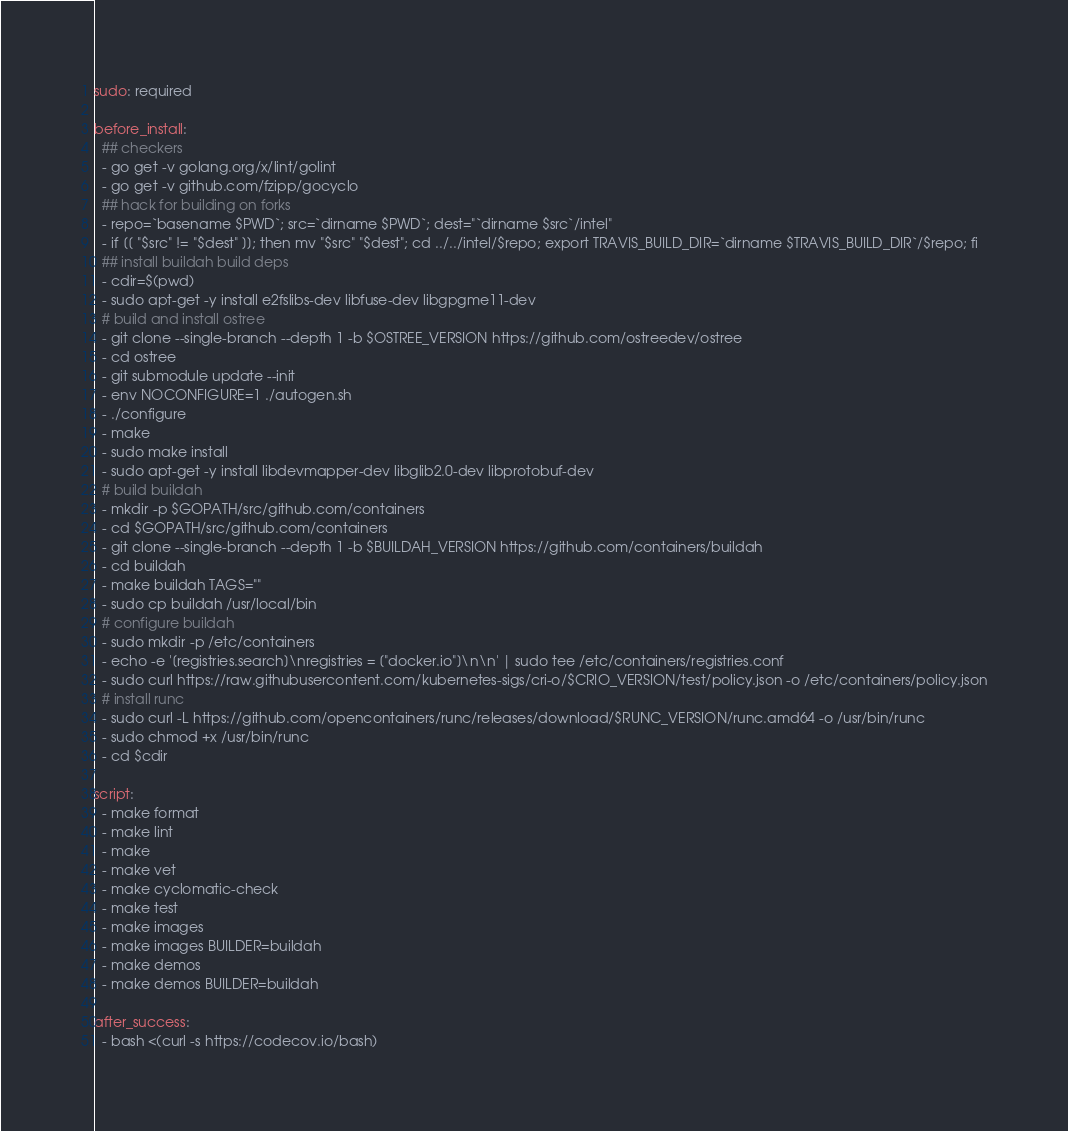Convert code to text. <code><loc_0><loc_0><loc_500><loc_500><_YAML_>
sudo: required

before_install:
  ## checkers
  - go get -v golang.org/x/lint/golint
  - go get -v github.com/fzipp/gocyclo
  ## hack for building on forks
  - repo=`basename $PWD`; src=`dirname $PWD`; dest="`dirname $src`/intel"
  - if [[ "$src" != "$dest" ]]; then mv "$src" "$dest"; cd ../../intel/$repo; export TRAVIS_BUILD_DIR=`dirname $TRAVIS_BUILD_DIR`/$repo; fi
  ## install buildah build deps
  - cdir=$(pwd)
  - sudo apt-get -y install e2fslibs-dev libfuse-dev libgpgme11-dev
  # build and install ostree
  - git clone --single-branch --depth 1 -b $OSTREE_VERSION https://github.com/ostreedev/ostree
  - cd ostree
  - git submodule update --init
  - env NOCONFIGURE=1 ./autogen.sh
  - ./configure
  - make
  - sudo make install
  - sudo apt-get -y install libdevmapper-dev libglib2.0-dev libprotobuf-dev
  # build buildah
  - mkdir -p $GOPATH/src/github.com/containers
  - cd $GOPATH/src/github.com/containers
  - git clone --single-branch --depth 1 -b $BUILDAH_VERSION https://github.com/containers/buildah
  - cd buildah
  - make buildah TAGS=""
  - sudo cp buildah /usr/local/bin
  # configure buildah
  - sudo mkdir -p /etc/containers
  - echo -e '[registries.search]\nregistries = ["docker.io"]\n\n' | sudo tee /etc/containers/registries.conf
  - sudo curl https://raw.githubusercontent.com/kubernetes-sigs/cri-o/$CRIO_VERSION/test/policy.json -o /etc/containers/policy.json
  # install runc
  - sudo curl -L https://github.com/opencontainers/runc/releases/download/$RUNC_VERSION/runc.amd64 -o /usr/bin/runc
  - sudo chmod +x /usr/bin/runc
  - cd $cdir

script:
  - make format
  - make lint
  - make
  - make vet
  - make cyclomatic-check
  - make test
  - make images
  - make images BUILDER=buildah
  - make demos
  - make demos BUILDER=buildah

after_success:
  - bash <(curl -s https://codecov.io/bash)
</code> 